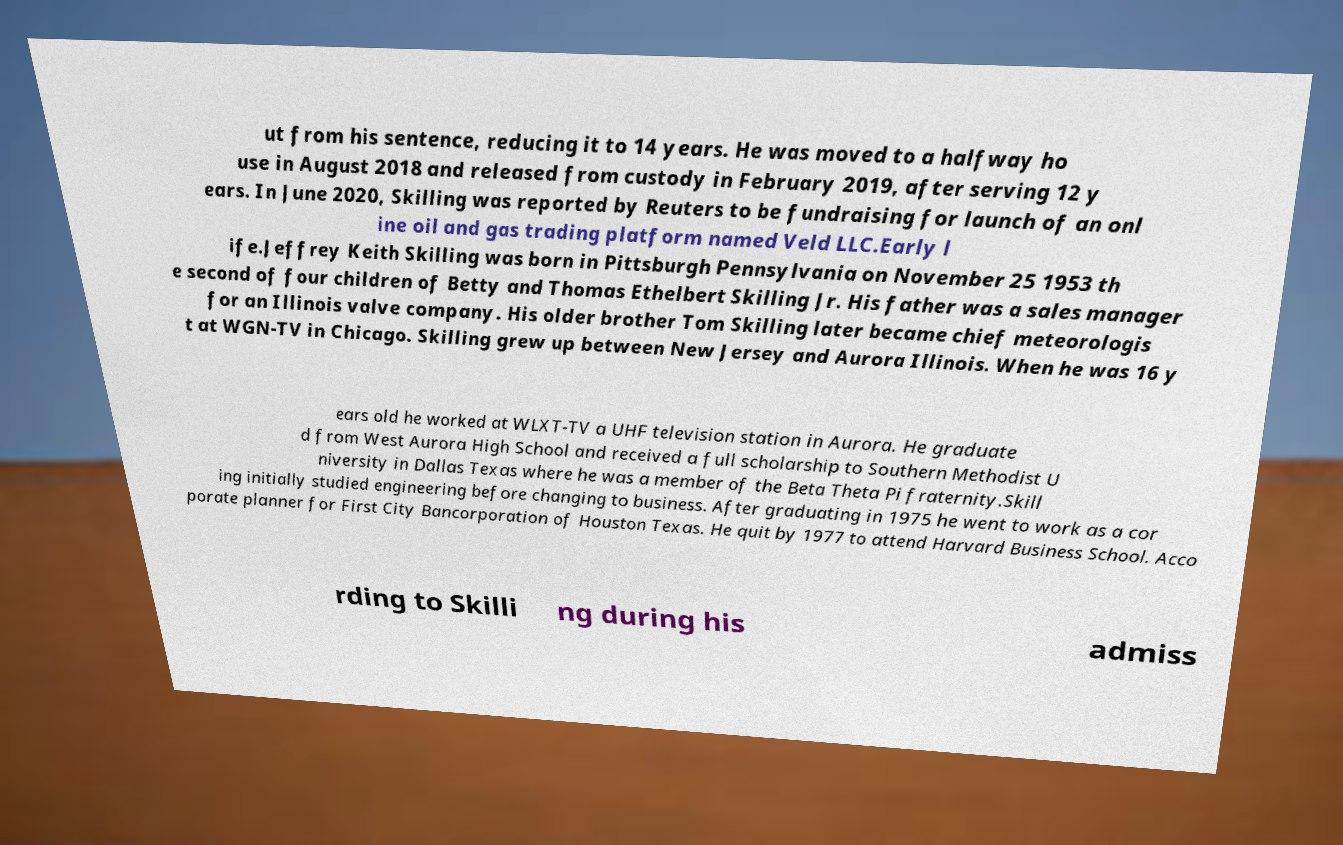Can you accurately transcribe the text from the provided image for me? ut from his sentence, reducing it to 14 years. He was moved to a halfway ho use in August 2018 and released from custody in February 2019, after serving 12 y ears. In June 2020, Skilling was reported by Reuters to be fundraising for launch of an onl ine oil and gas trading platform named Veld LLC.Early l ife.Jeffrey Keith Skilling was born in Pittsburgh Pennsylvania on November 25 1953 th e second of four children of Betty and Thomas Ethelbert Skilling Jr. His father was a sales manager for an Illinois valve company. His older brother Tom Skilling later became chief meteorologis t at WGN-TV in Chicago. Skilling grew up between New Jersey and Aurora Illinois. When he was 16 y ears old he worked at WLXT-TV a UHF television station in Aurora. He graduate d from West Aurora High School and received a full scholarship to Southern Methodist U niversity in Dallas Texas where he was a member of the Beta Theta Pi fraternity.Skill ing initially studied engineering before changing to business. After graduating in 1975 he went to work as a cor porate planner for First City Bancorporation of Houston Texas. He quit by 1977 to attend Harvard Business School. Acco rding to Skilli ng during his admiss 